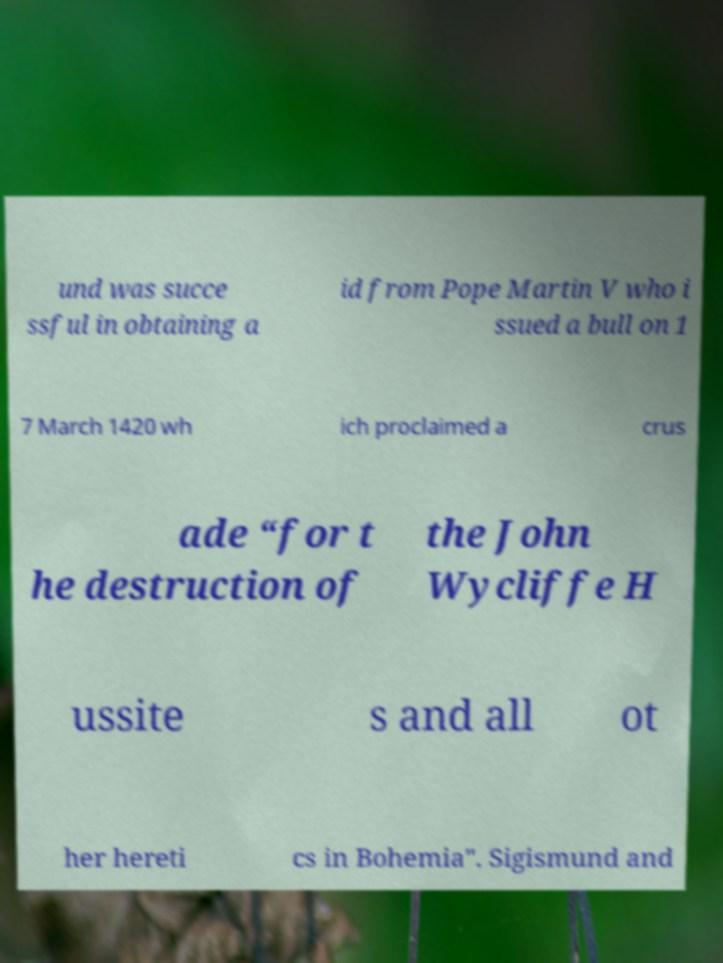Can you accurately transcribe the text from the provided image for me? und was succe ssful in obtaining a id from Pope Martin V who i ssued a bull on 1 7 March 1420 wh ich proclaimed a crus ade “for t he destruction of the John Wycliffe H ussite s and all ot her hereti cs in Bohemia". Sigismund and 